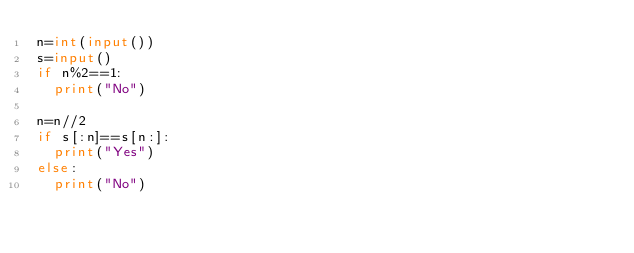<code> <loc_0><loc_0><loc_500><loc_500><_Python_>n=int(input())
s=input()
if n%2==1:
  print("No")

n=n//2
if s[:n]==s[n:]:
  print("Yes")
else:
  print("No")
  
</code> 